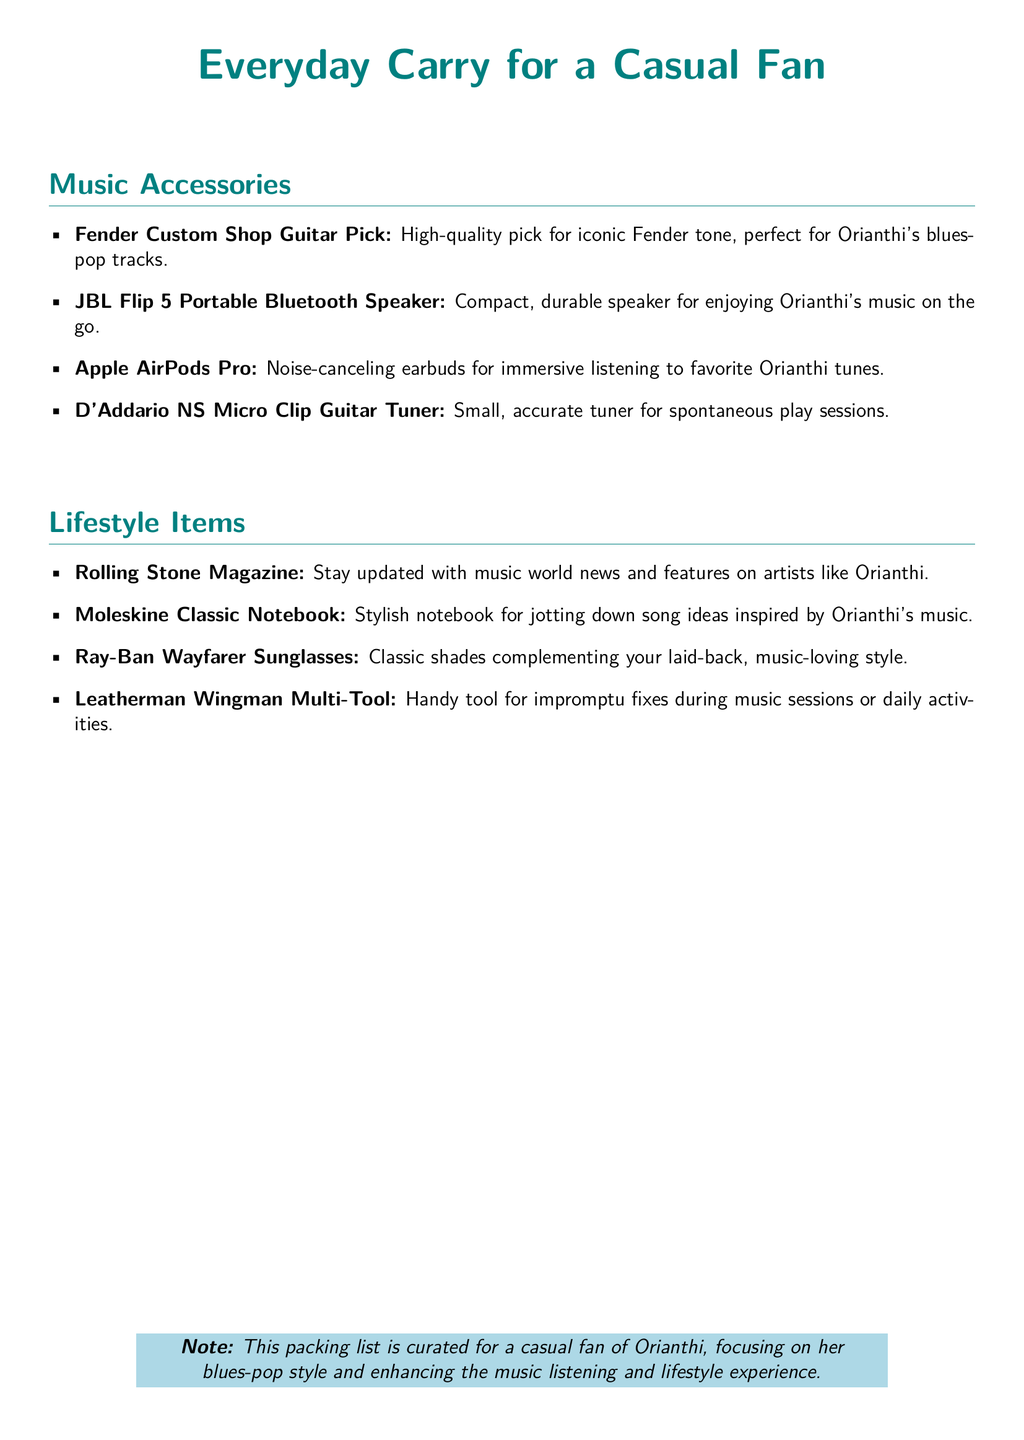What is the first item in the Music Accessories section? The first item listed in the Music Accessories section is a Fender Custom Shop Guitar Pick.
Answer: Fender Custom Shop Guitar Pick How many items are listed under Lifestyle Items? The Lifestyle Items section includes four items.
Answer: 4 What type of sunglasses are mentioned in the Lifestyle Items? The document specifies Ray-Ban Wayfarer Sunglasses.
Answer: Ray-Ban Wayfarer Sunglasses What is a recommended item for spontaneous play sessions? The recommended item for spontaneous play sessions is a D'Addario NS Micro Clip Guitar Tuner.
Answer: D'Addario NS Micro Clip Guitar Tuner Which portable speaker is suggested for enjoying Orianthi's music? The JBL Flip 5 Portable Bluetooth Speaker is suggested for listening to her music.
Answer: JBL Flip 5 Portable Bluetooth Speaker What type of notebook is mentioned for jotting down song ideas? The document recommends a Moleskine Classic Notebook for this purpose.
Answer: Moleskine Classic Notebook Which magazine is included for keeping up with music news? Rolling Stone Magazine is the publication mentioned for music news.
Answer: Rolling Stone Magazine What is the focus of the packing list? The packing list is curated for casual fans of Orianthi, focusing on her blues-pop style.
Answer: Casual fans of Orianthi, focusing on her blues-pop style 